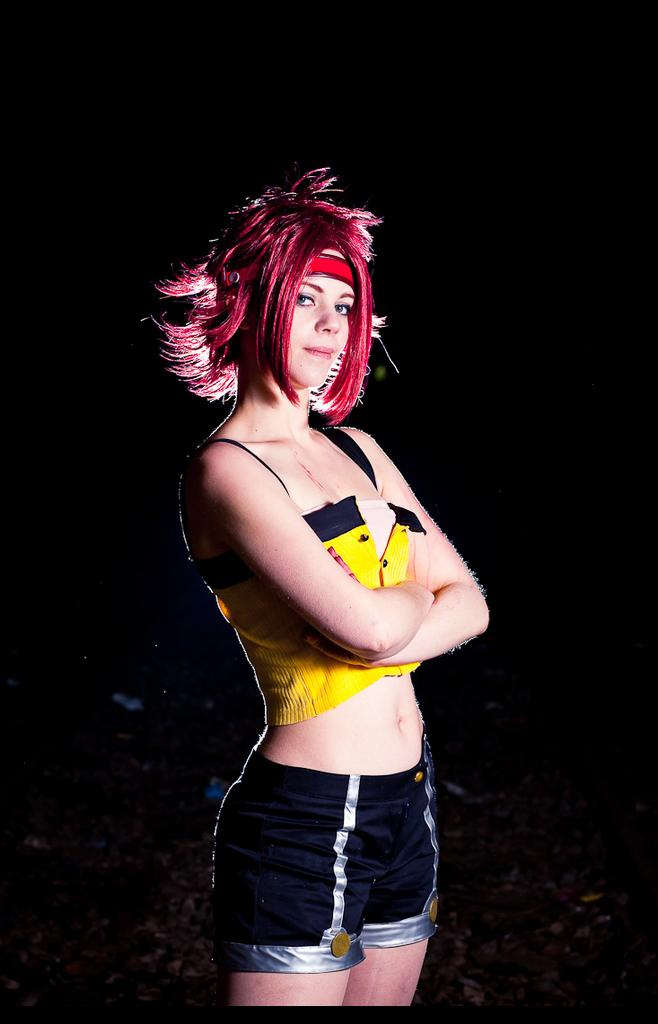Who is the main subject in the image? There is a woman in the image. What is the woman doing in the image? The woman is standing. What color is the woman's top in the image? The woman is wearing a yellow top. What color are the woman's shorts in the image? The woman is wearing black shorts. What is the color of the woman's hair in the image? The woman's hair color is red. How many mice can be seen running around the woman's feet in the image? There are no mice present in the image, and therefore no mice can be seen running around the woman's feet. 